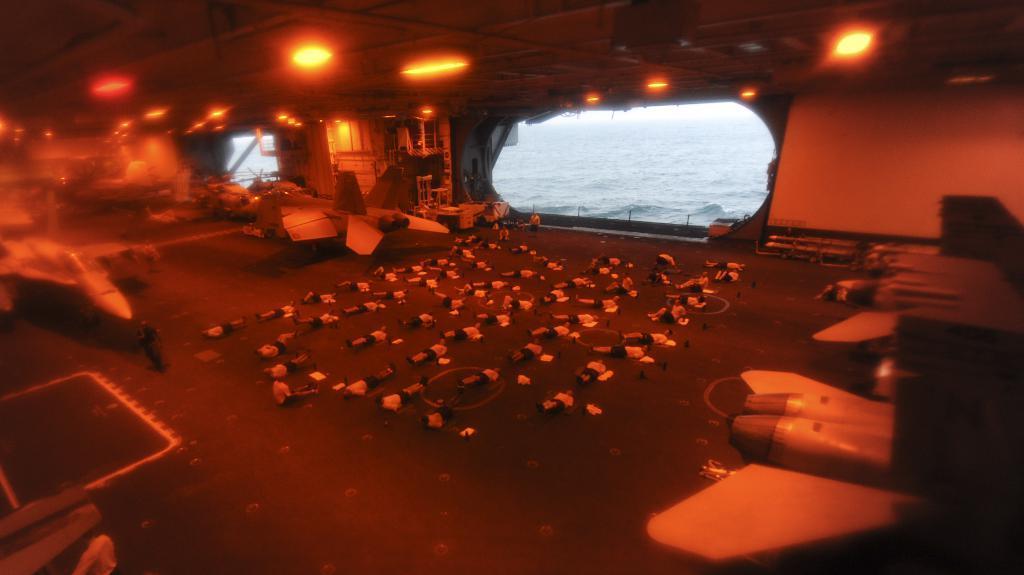Describe this image in one or two sentences. This is the inside view of a ship in which there are some aircrafts and some other objects lights in the ship there are two glass windows through which we can see water. 